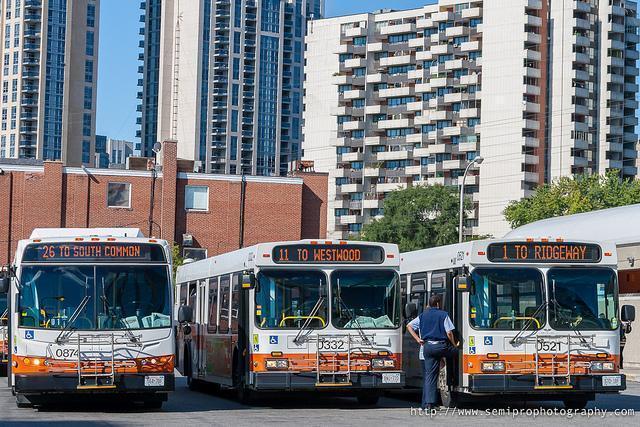The man standing near the buses is probably there to do what?
Make your selection from the four choices given to correctly answer the question.
Options: Get directions, travel, drive, sight-see. Drive. 